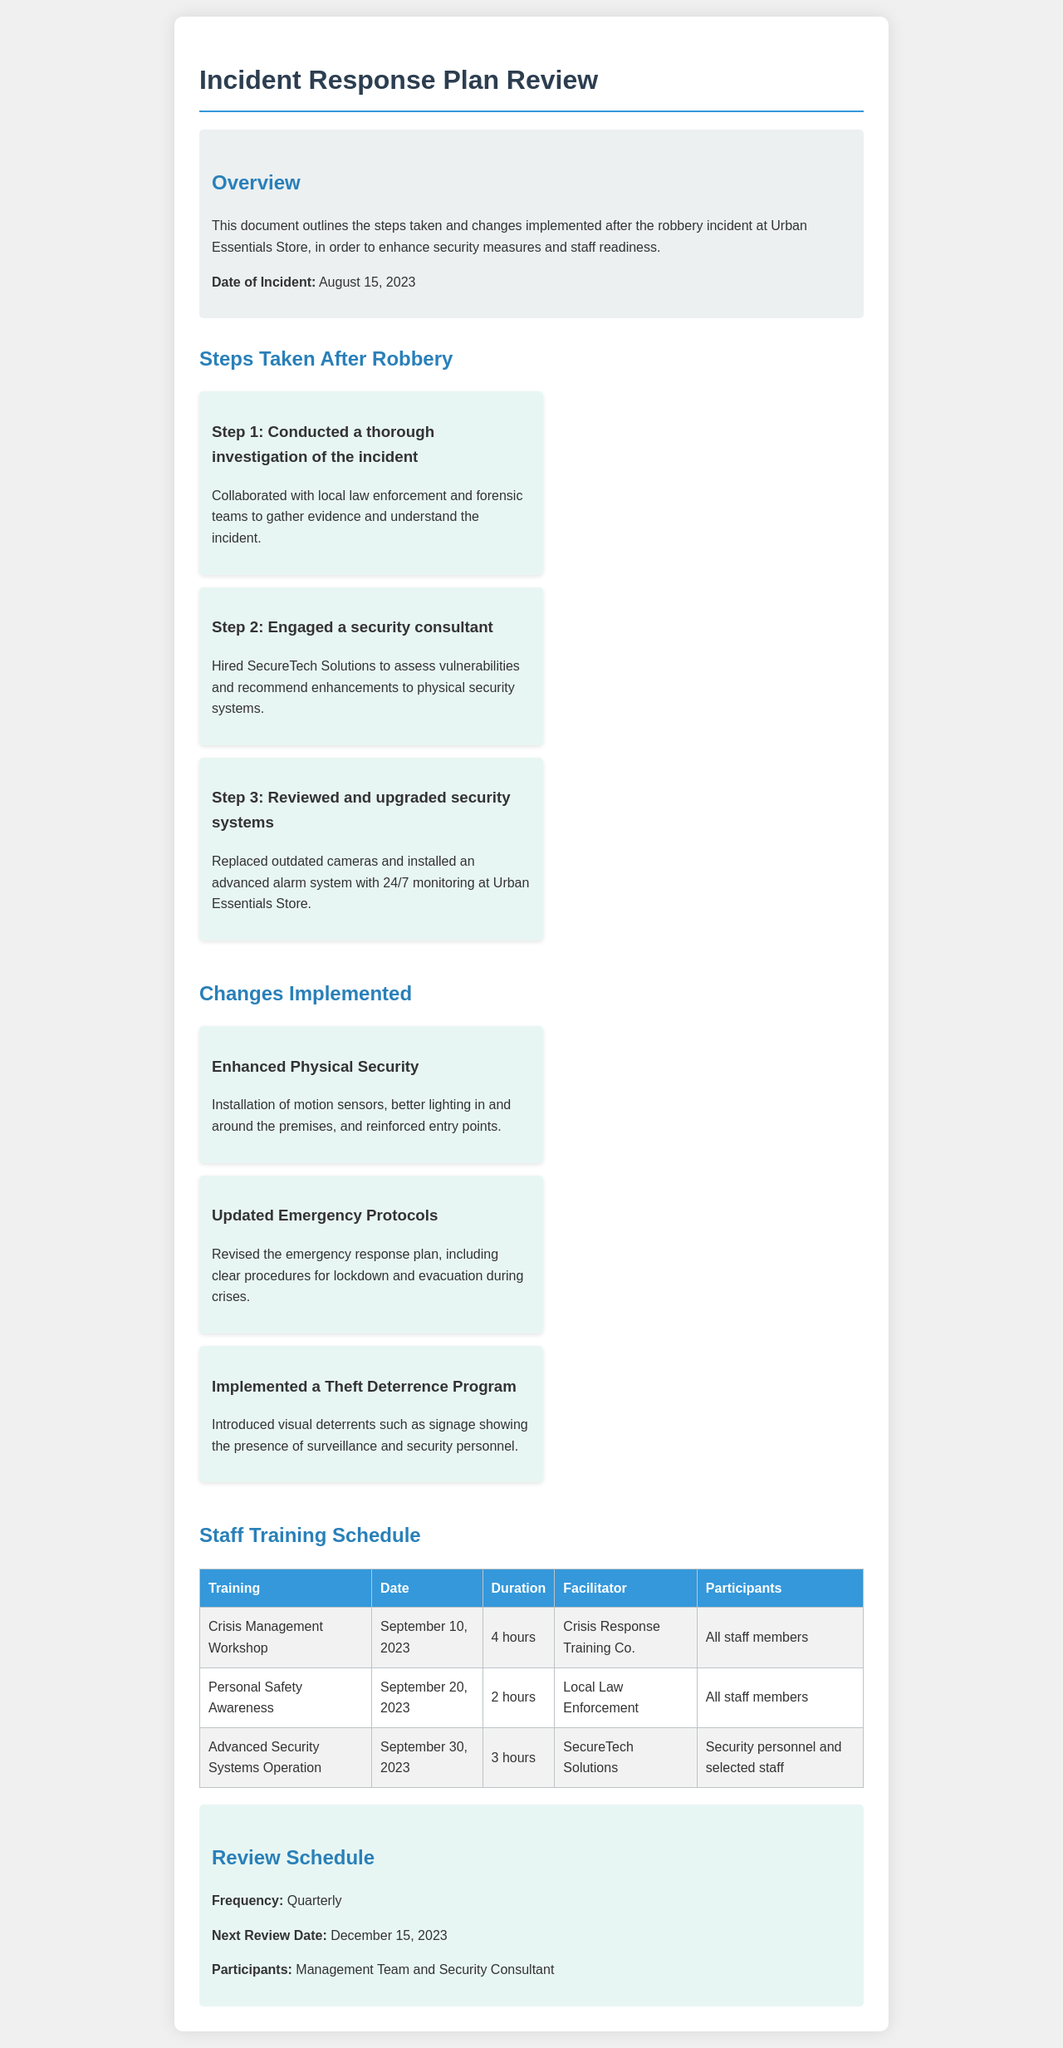What is the date of the robbery incident? The date of the robbery incident is mentioned in the overview section of the document.
Answer: August 15, 2023 Who conducted the crisis management workshop? The facilitator of the crisis management workshop is noted in the staff training schedule section.
Answer: Crisis Response Training Co How many hours is the personal safety awareness training? The duration of the personal safety awareness training is specified in the table of the staff training schedule.
Answer: 2 hours What security consultant was engaged after the robbery? The name of the security consultant is listed in the steps taken after the robbery section.
Answer: SecureTech Solutions What is the frequency of the review schedule? The frequency of the review schedule is stated in the review schedule section of the document.
Answer: Quarterly What changes were made to emergency protocols? The document specifies that emergency protocols were updated, focusing on procedures for crises.
Answer: Updated Emergency Protocols Who are the participants for the advanced security systems operation training? The participants for the advanced security systems operation training are listed in the staff training schedule.
Answer: Security personnel and selected staff What is the next review date for the incident response plan? The next review date is indicated in the review schedule section of the document.
Answer: December 15, 2023 